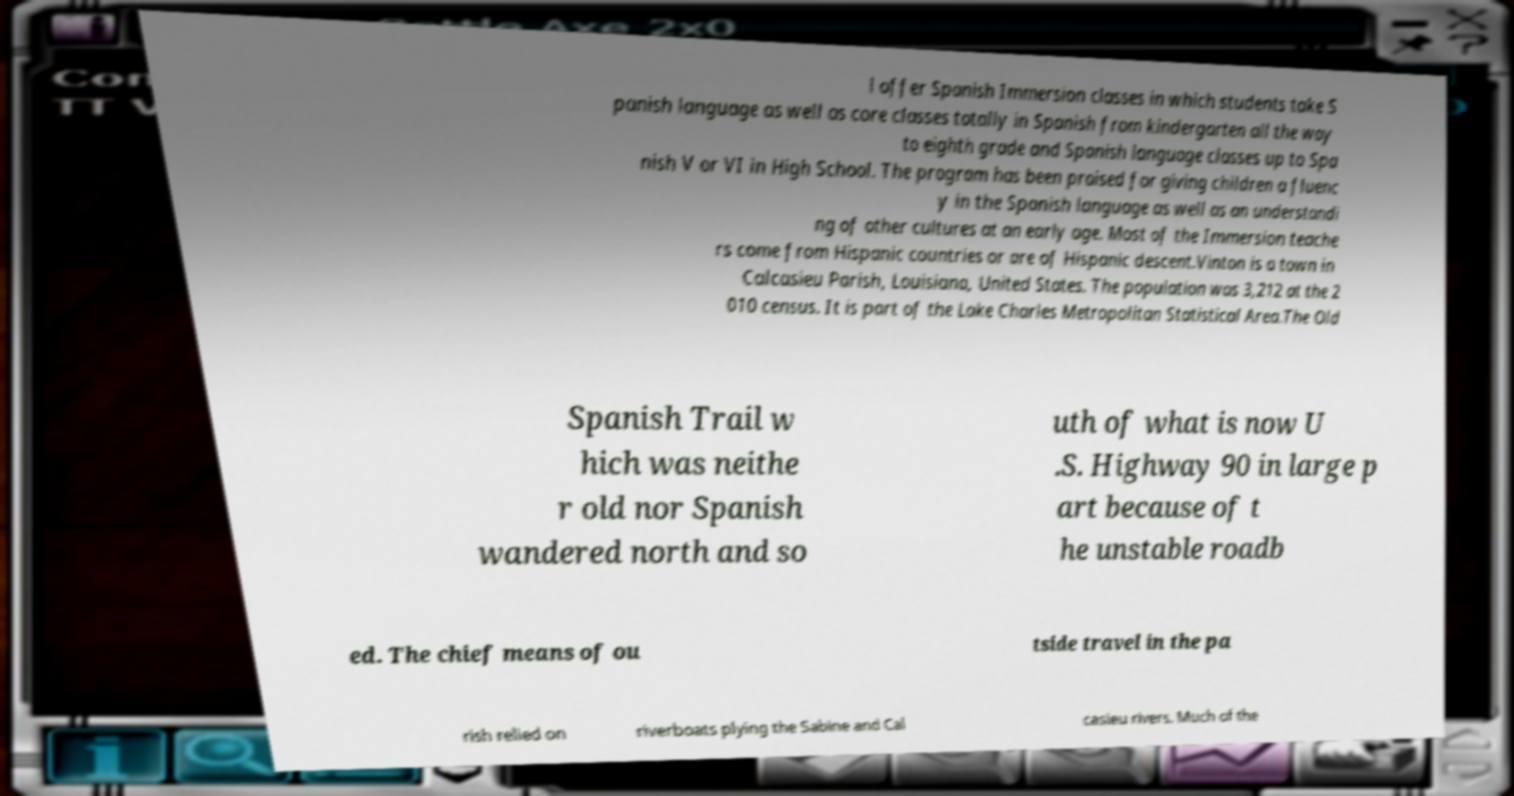Please identify and transcribe the text found in this image. l offer Spanish Immersion classes in which students take S panish language as well as core classes totally in Spanish from kindergarten all the way to eighth grade and Spanish language classes up to Spa nish V or VI in High School. The program has been praised for giving children a fluenc y in the Spanish language as well as an understandi ng of other cultures at an early age. Most of the Immersion teache rs come from Hispanic countries or are of Hispanic descent.Vinton is a town in Calcasieu Parish, Louisiana, United States. The population was 3,212 at the 2 010 census. It is part of the Lake Charles Metropolitan Statistical Area.The Old Spanish Trail w hich was neithe r old nor Spanish wandered north and so uth of what is now U .S. Highway 90 in large p art because of t he unstable roadb ed. The chief means of ou tside travel in the pa rish relied on riverboats plying the Sabine and Cal casieu rivers. Much of the 